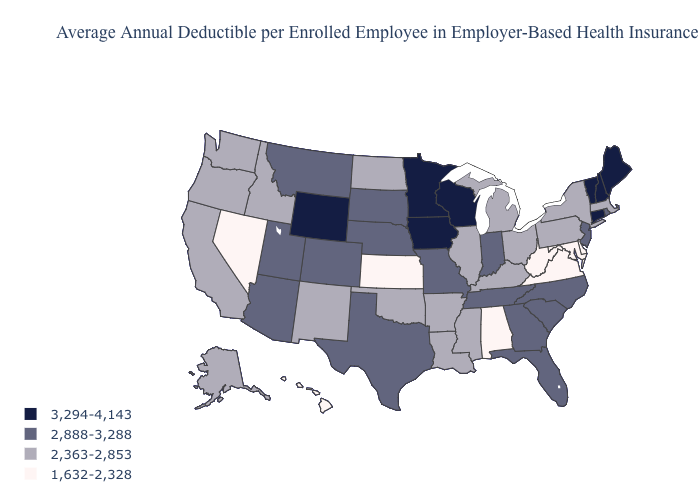What is the highest value in the Northeast ?
Write a very short answer. 3,294-4,143. Name the states that have a value in the range 1,632-2,328?
Write a very short answer. Alabama, Delaware, Hawaii, Kansas, Maryland, Nevada, Virginia, West Virginia. What is the lowest value in states that border Connecticut?
Keep it brief. 2,363-2,853. Does the first symbol in the legend represent the smallest category?
Quick response, please. No. What is the lowest value in the USA?
Short answer required. 1,632-2,328. Name the states that have a value in the range 1,632-2,328?
Concise answer only. Alabama, Delaware, Hawaii, Kansas, Maryland, Nevada, Virginia, West Virginia. Does New Jersey have the highest value in the Northeast?
Concise answer only. No. Which states have the lowest value in the Northeast?
Give a very brief answer. Massachusetts, New York, Pennsylvania. Name the states that have a value in the range 2,363-2,853?
Be succinct. Alaska, Arkansas, California, Idaho, Illinois, Kentucky, Louisiana, Massachusetts, Michigan, Mississippi, New Mexico, New York, North Dakota, Ohio, Oklahoma, Oregon, Pennsylvania, Washington. Name the states that have a value in the range 3,294-4,143?
Give a very brief answer. Connecticut, Iowa, Maine, Minnesota, New Hampshire, Vermont, Wisconsin, Wyoming. What is the value of New York?
Quick response, please. 2,363-2,853. Does Indiana have the lowest value in the MidWest?
Concise answer only. No. Name the states that have a value in the range 2,888-3,288?
Concise answer only. Arizona, Colorado, Florida, Georgia, Indiana, Missouri, Montana, Nebraska, New Jersey, North Carolina, Rhode Island, South Carolina, South Dakota, Tennessee, Texas, Utah. Does Ohio have the same value as North Dakota?
Quick response, please. Yes. Is the legend a continuous bar?
Quick response, please. No. 